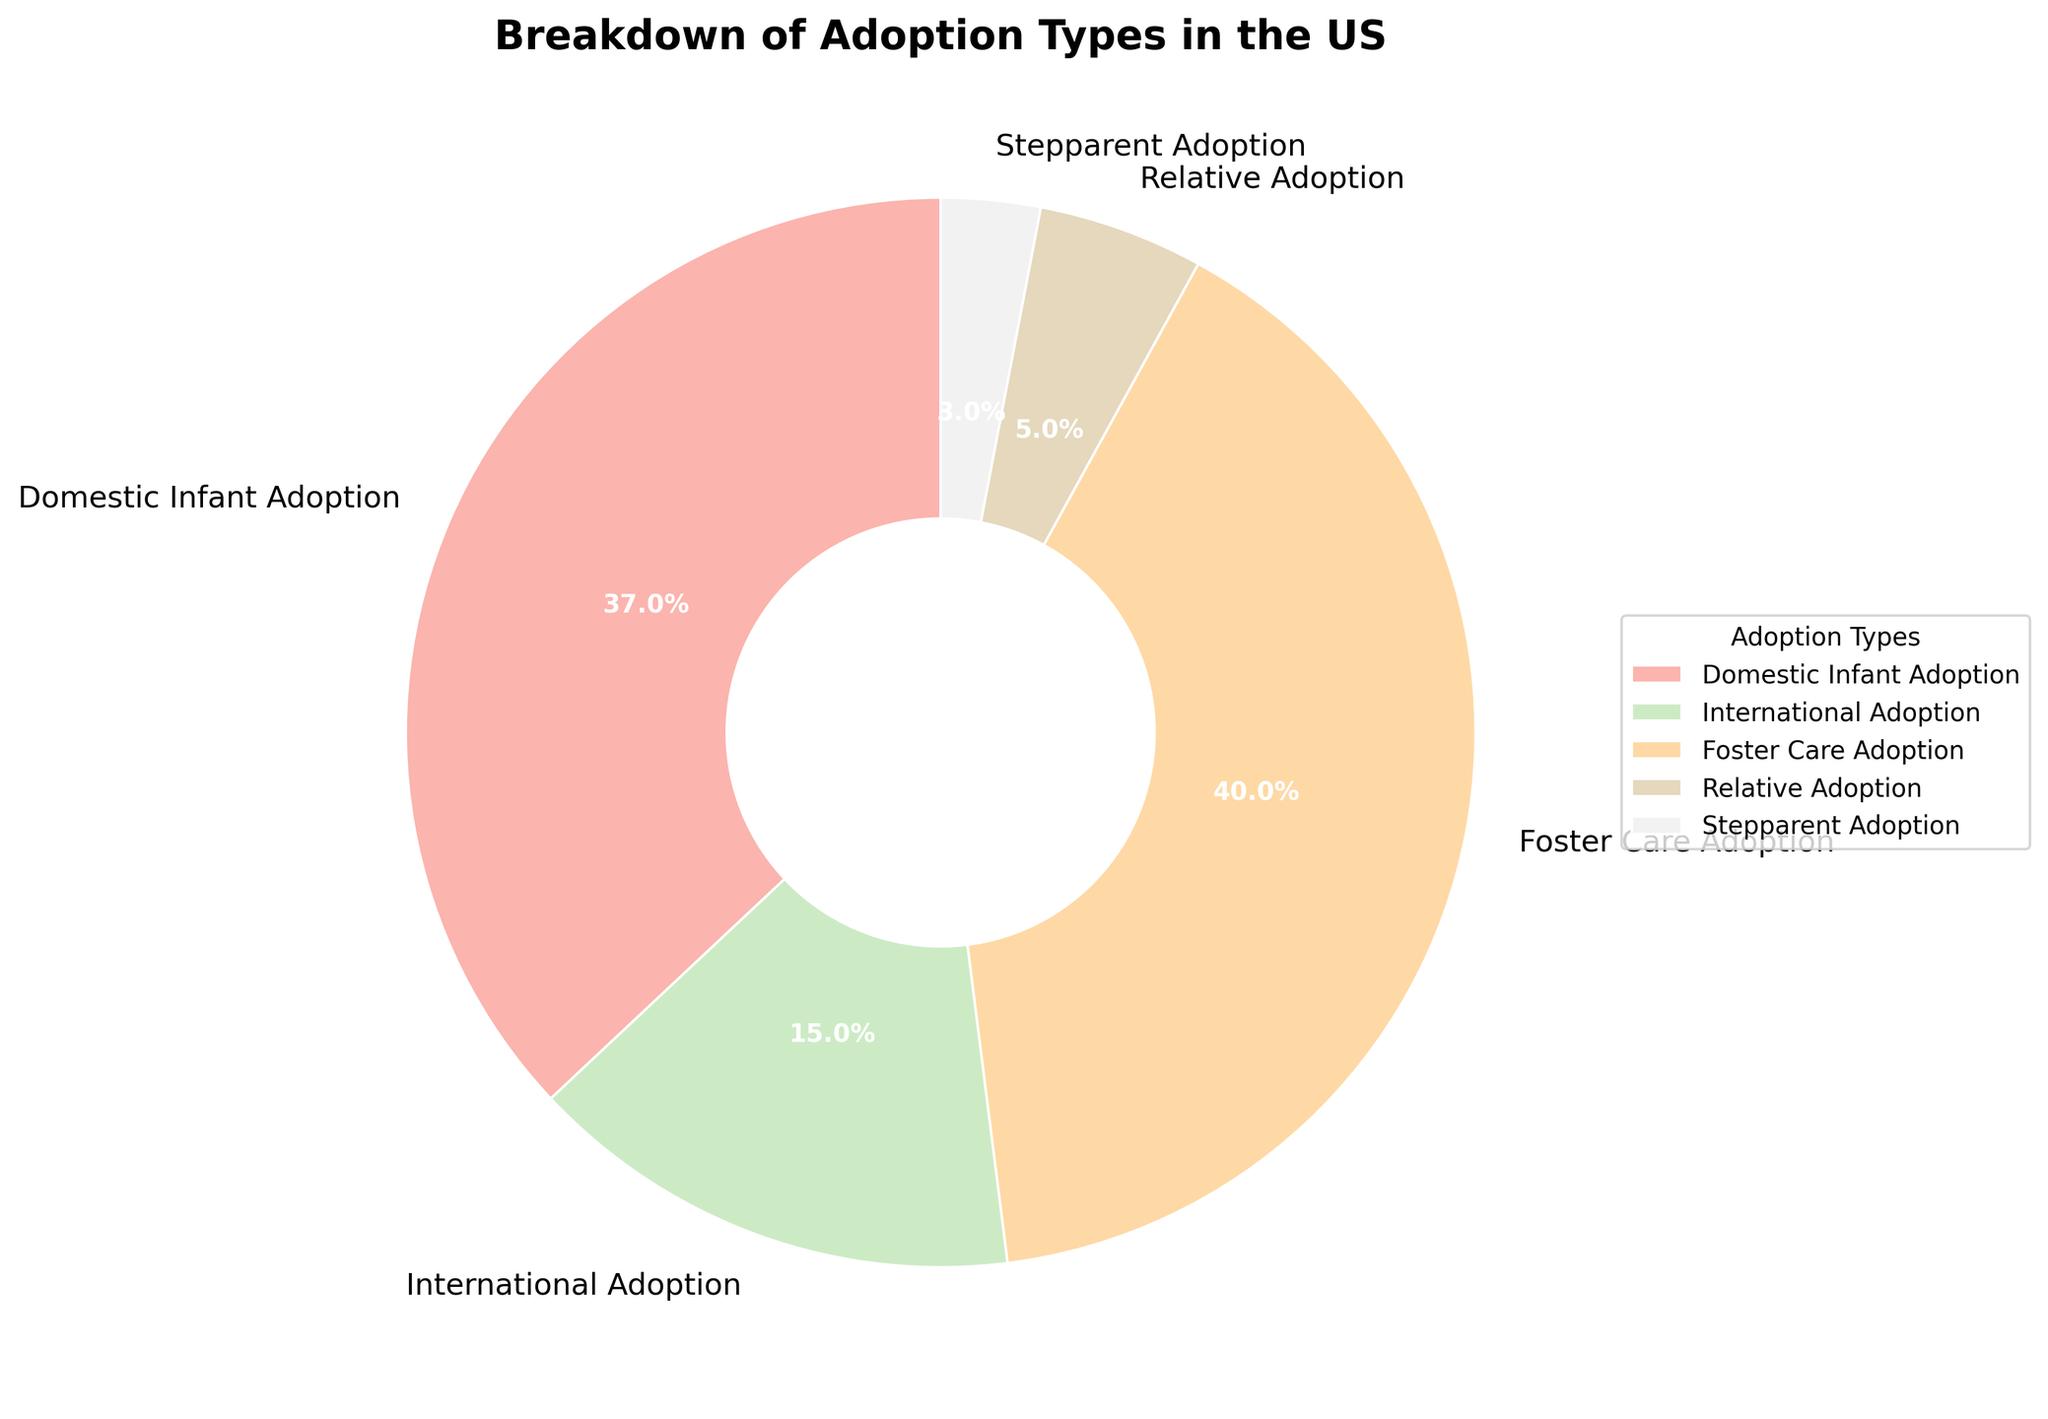Which adoption type has the highest percentage? The pie chart shows that Foster Care Adoption has the largest segment, which represents the highest percentage of 40%.
Answer: Foster Care Adoption Which adoption type has the lowest percentage? By looking at the smallest segment in the pie chart, we see that Stepparent Adoption has the lowest percentage of 3%.
Answer: Stepparent Adoption What is the total percentage of Domestic Infant Adoption and International Adoption combined? Sum the percentages of Domestic Infant Adoption (37%) and International Adoption (15%): 37% + 15% = 52%.
Answer: 52% Which has a higher percentage, Relative Adoption or International Adoption, and by how much? The percentage for Relative Adoption is 5% and for International Adoption is 15%. The difference is 15% - 5% = 10%.
Answer: International Adoption by 10% What portion of the pie chart is represented by adoptions other than Foster Care Adoption? Subtract the percentage of Foster Care Adoption (40%) from 100%: 100% - 40% = 60%.
Answer: 60% Does Domestic Infant Adoption make up more or less than a third of the pie chart? Domestic Infant Adoption is 37%, which is more than one-third (33.33%) of the pie chart.
Answer: More What is the difference in percentage between Domestic Infant Adoption and Foster Care Adoption? Subtract the percentage of Domestic Infant Adoption (37%) from Foster Care Adoption (40%): 40% - 37% = 3%.
Answer: 3% Visualize the largest and second-largest segments; what adoption types do these correspond to and what is their combined percentage? The largest segment is Foster Care Adoption (40%) and the second-largest is Domestic Infant Adoption (37%). Their combined percentage is 40% + 37% = 77%.
Answer: Foster Care Adoption and Domestic Infant Adoption, 77% Which color represents Stepparent Adoption, and what percentage does it cover? The pie chart segment for Stepparent Adoption is represented by the color and covers 3%.
Answer: 3% 